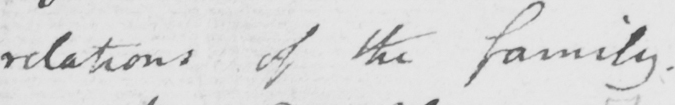What text is written in this handwritten line? relations of the family . 